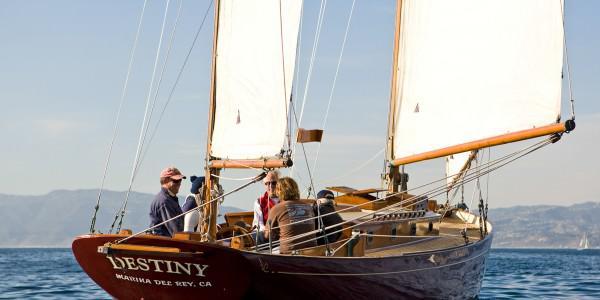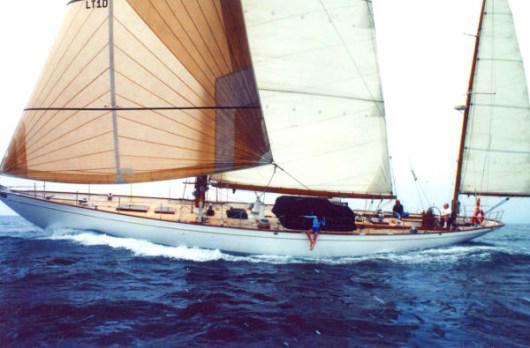The first image is the image on the left, the second image is the image on the right. Considering the images on both sides, is "In at least one image there is a sail boat with four open sails." valid? Answer yes or no. No. The first image is the image on the left, the second image is the image on the right. Considering the images on both sides, is "Two sailboats on open water are headed in the same direction, but only one has a flag flying from the stern." valid? Answer yes or no. No. 